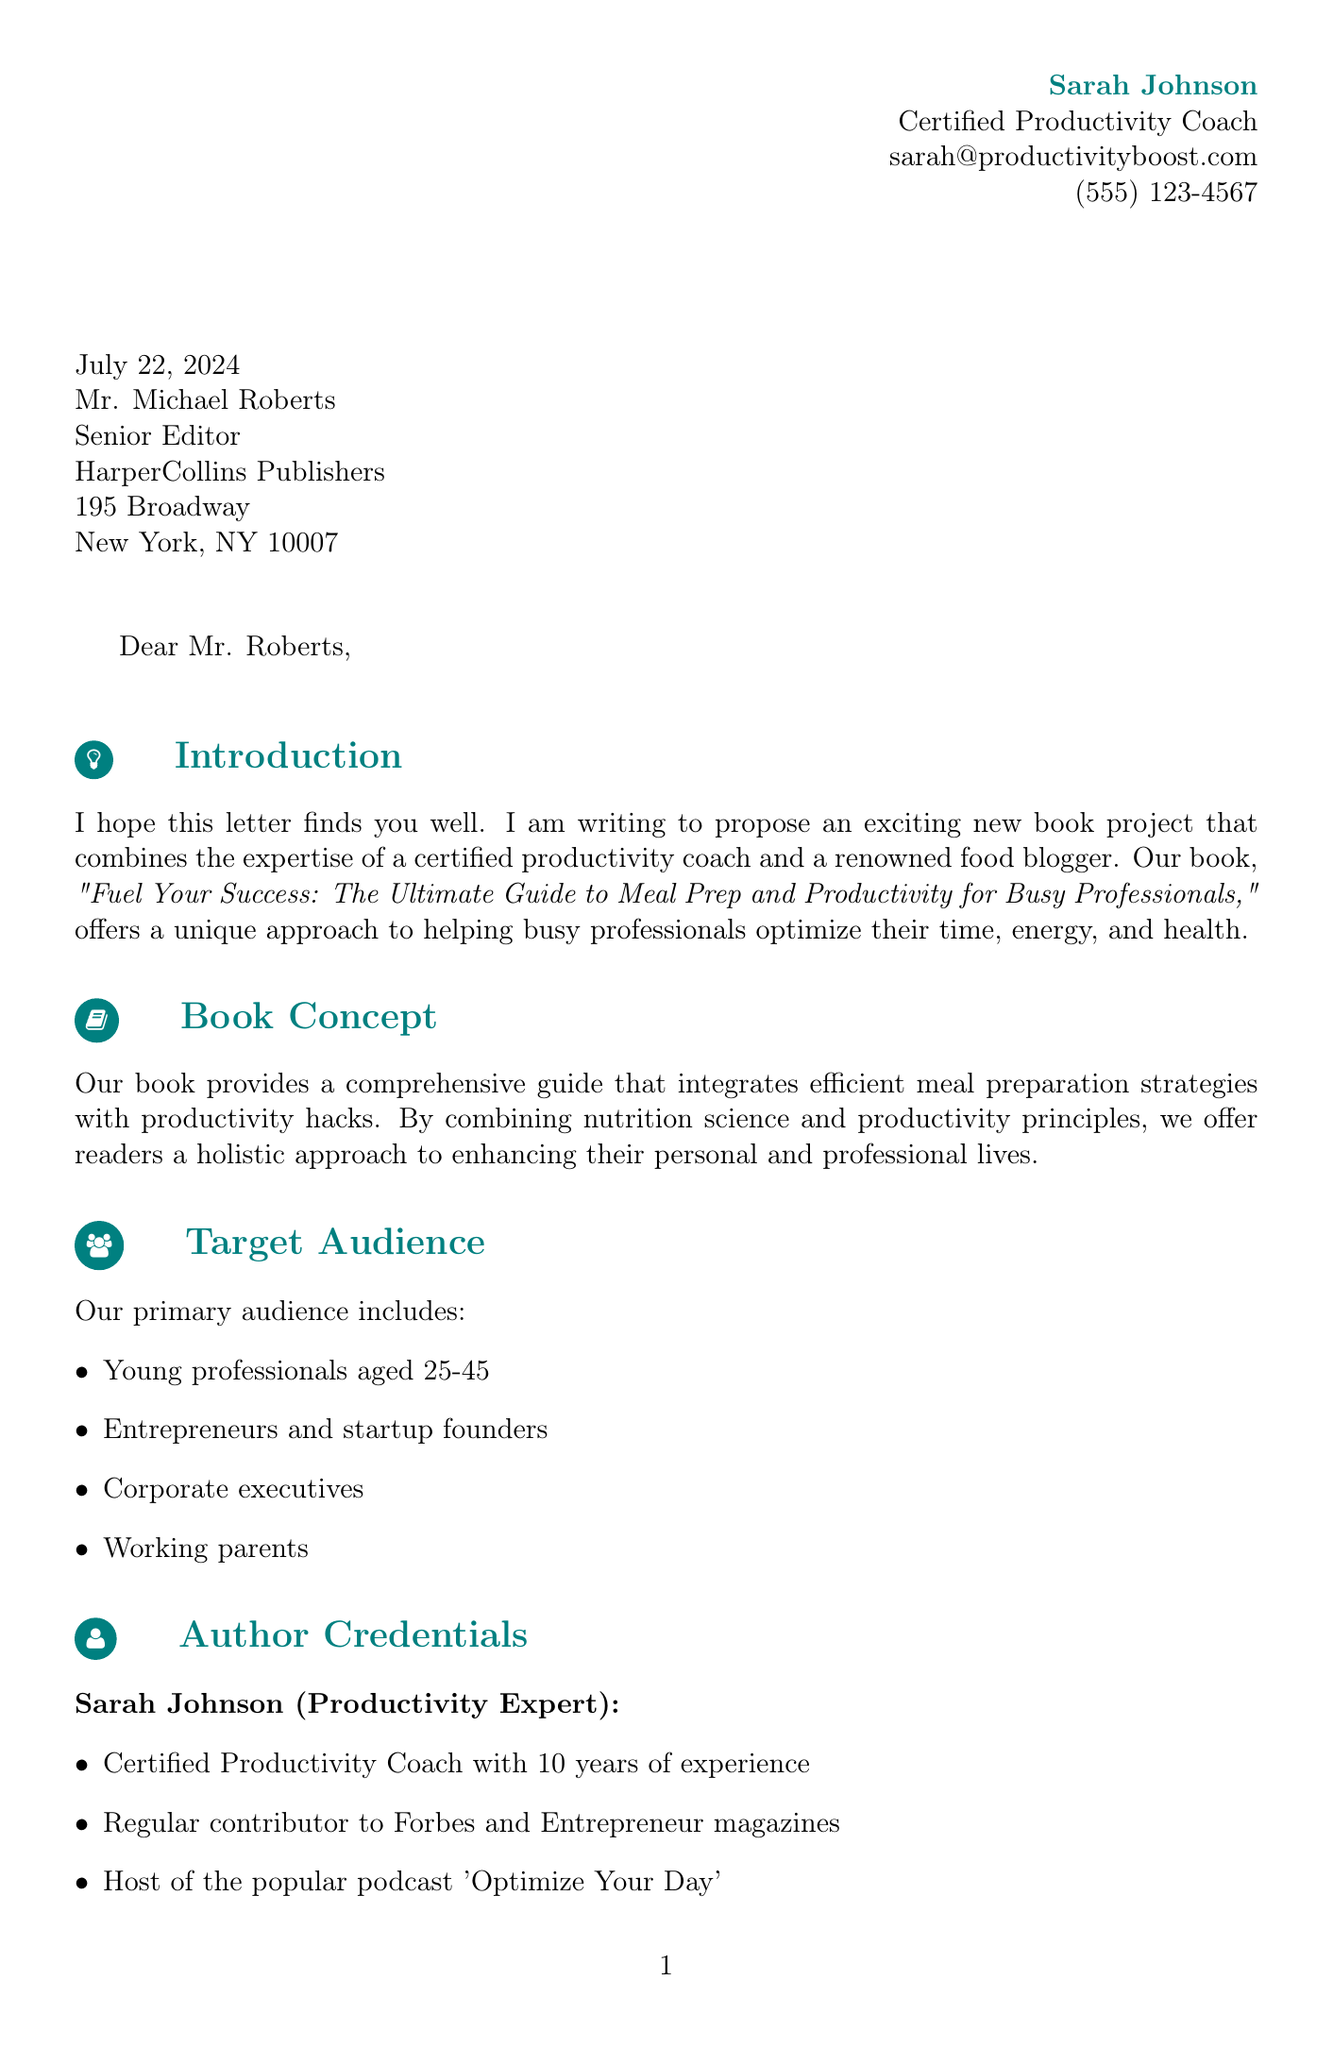what is the title of the book? The title of the book is mentioned in the introduction section of the letter.
Answer: Fuel Your Success: The Ultimate Guide to Meal Prep and Productivity for Busy Professionals who are the authors of the book? The authors of the book are stated in the document specifically in the author credentials section.
Answer: Sarah Johnson and Emily Chen what is the target audience age range? The target audience includes young professionals aged 25-45 according to the target audience section.
Answer: 25-45 what is one unique selling point of the book? The unique selling points are outlined in the respective section of the document.
Answer: Integration of nutrition science with productivity principles how many years of experience does Sarah Johnson have as a Productivity Coach? The document mentions Sarah Johnson's experience in the author credentials section.
Answer: 10 years what notable role does Emily Chen have in the food blogging community? Emily Chen's credentials provide insight into her significance in the food blogging niche.
Answer: Professional food blogger with over 500,000 followers what is the projected market value of the meal kit delivery market by 2027? This statistic is included in the market potential section of the letter.
Answer: $20 billion what marketing strategy involves live interaction? The marketing plan highlights various strategies, including one involving live engagement.
Answer: Virtual book tour with live cooking and productivity workshops what type of book does this letter propose? The document clearly outlines the nature of the proposed book in relation to meal prep and productivity.
Answer: A comprehensive guide that combines efficient meal preparation strategies with productivity hacks 